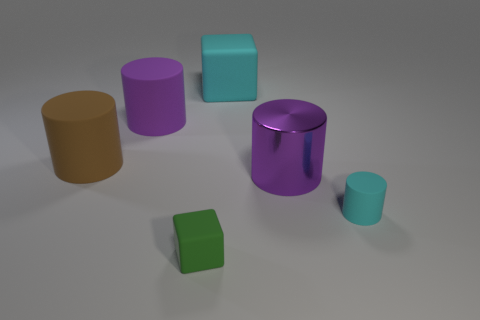How many brown objects are big objects or big shiny things?
Your response must be concise. 1. Is there a tiny gray metallic thing?
Provide a succinct answer. No. There is a cyan thing in front of the big cylinder that is on the right side of the big rubber block; is there a tiny cyan matte cylinder that is to the right of it?
Your answer should be very brief. No. Is there anything else that is the same size as the brown object?
Give a very brief answer. Yes. Does the brown object have the same shape as the object in front of the tiny cyan rubber cylinder?
Provide a succinct answer. No. There is a rubber object that is behind the big purple object behind the brown object left of the big matte cube; what color is it?
Make the answer very short. Cyan. How many objects are either matte blocks behind the tiny rubber cylinder or cyan things behind the small cyan rubber thing?
Your answer should be very brief. 1. How many other things are the same color as the large rubber block?
Offer a very short reply. 1. Is the shape of the cyan thing in front of the brown cylinder the same as  the small green thing?
Keep it short and to the point. No. Are there fewer large purple things behind the metal object than small green objects?
Provide a succinct answer. No. 